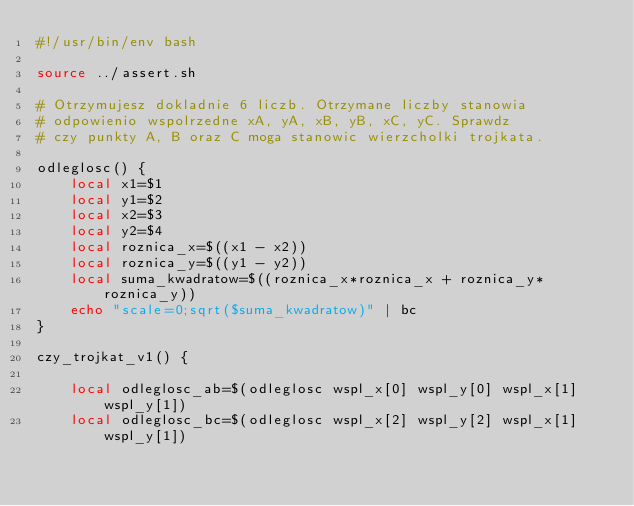Convert code to text. <code><loc_0><loc_0><loc_500><loc_500><_Bash_>#!/usr/bin/env bash

source ../assert.sh

# Otrzymujesz dokladnie 6 liczb. Otrzymane liczby stanowia
# odpowienio wspolrzedne xA, yA, xB, yB, xC, yC. Sprawdz
# czy punkty A, B oraz C moga stanowic wierzcholki trojkata.

odleglosc() {
    local x1=$1
    local y1=$2
    local x2=$3
    local y2=$4
    local roznica_x=$((x1 - x2))
    local roznica_y=$((y1 - y2))
    local suma_kwadratow=$((roznica_x*roznica_x + roznica_y*roznica_y))
    echo "scale=0;sqrt($suma_kwadratow)" | bc
}

czy_trojkat_v1() {

    local odleglosc_ab=$(odleglosc wspl_x[0] wspl_y[0] wspl_x[1] wspl_y[1])
    local odleglosc_bc=$(odleglosc wspl_x[2] wspl_y[2] wspl_x[1] wspl_y[1])</code> 